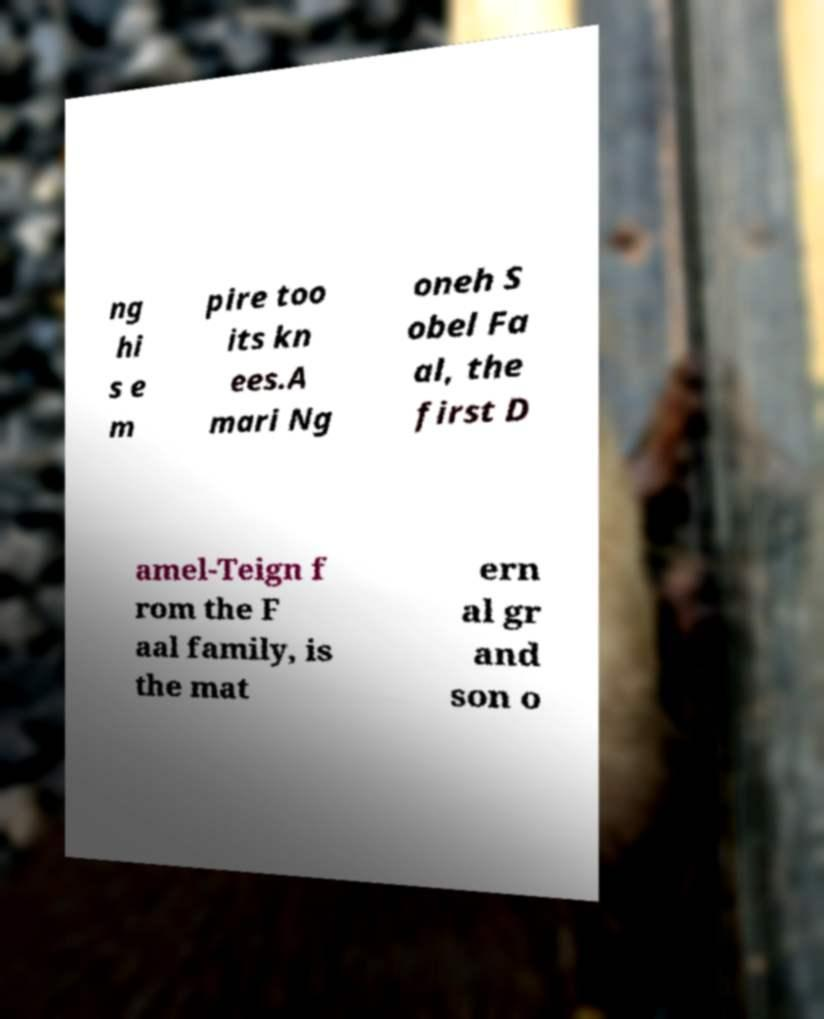Please identify and transcribe the text found in this image. ng hi s e m pire too its kn ees.A mari Ng oneh S obel Fa al, the first D amel-Teign f rom the F aal family, is the mat ern al gr and son o 